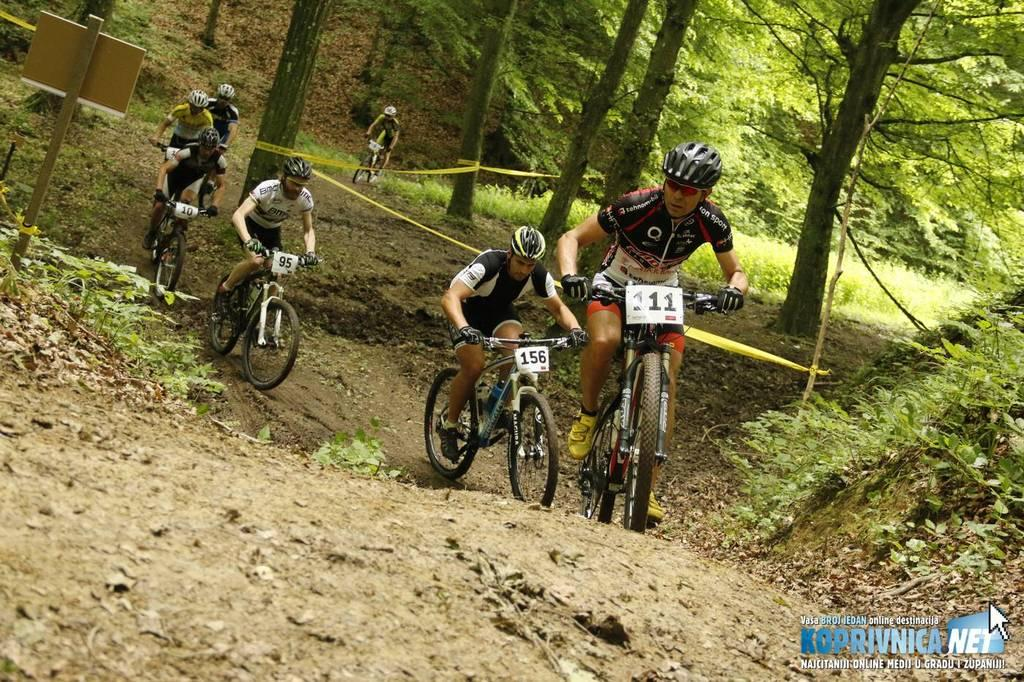What are the people in the image doing? The people in the image are riding bicycles. What safety precaution are the people taking while riding bicycles? The people are wearing helmets. What type of natural elements can be seen in the image? There are trees in the image. What type of vegetation can be seen growing on the trees or nearby structures? There are creeps (possibly referring to creepers or vines) present in the image. What type of writing can be seen on the bicycle wheels in the image? There is no writing visible on the bicycle wheels in the image. What is the thumb doing in the image? There is no thumb present in the image. Is there a pear visible in the image? There is no pear present in the image. 